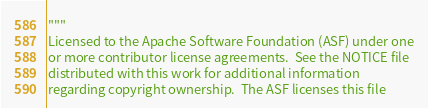Convert code to text. <code><loc_0><loc_0><loc_500><loc_500><_Python_>"""
Licensed to the Apache Software Foundation (ASF) under one
or more contributor license agreements.  See the NOTICE file
distributed with this work for additional information
regarding copyright ownership.  The ASF licenses this file</code> 